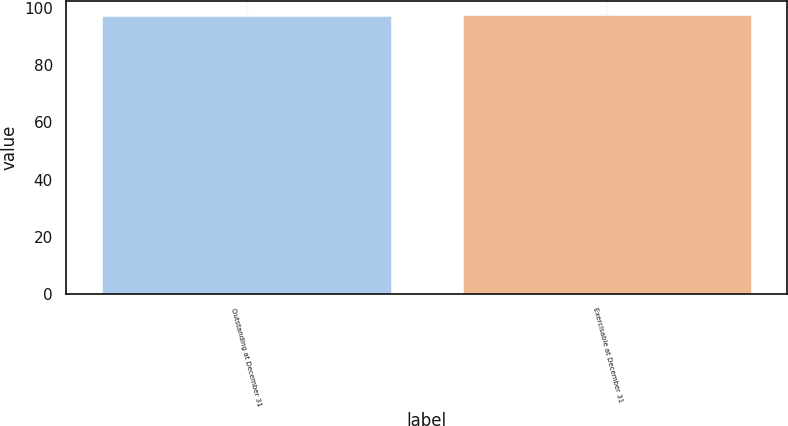Convert chart to OTSL. <chart><loc_0><loc_0><loc_500><loc_500><bar_chart><fcel>Outstanding at December 31<fcel>Exercisable at December 31<nl><fcel>97.35<fcel>97.49<nl></chart> 